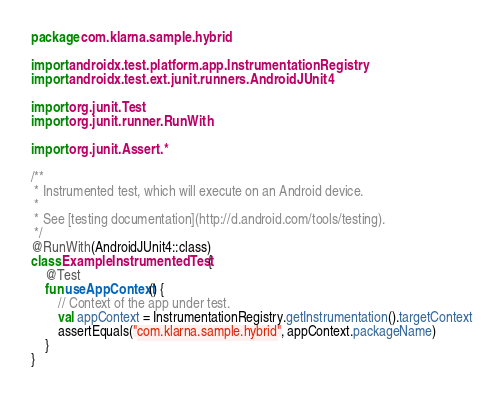Convert code to text. <code><loc_0><loc_0><loc_500><loc_500><_Kotlin_>package com.klarna.sample.hybrid

import androidx.test.platform.app.InstrumentationRegistry
import androidx.test.ext.junit.runners.AndroidJUnit4

import org.junit.Test
import org.junit.runner.RunWith

import org.junit.Assert.*

/**
 * Instrumented test, which will execute on an Android device.
 *
 * See [testing documentation](http://d.android.com/tools/testing).
 */
@RunWith(AndroidJUnit4::class)
class ExampleInstrumentedTest {
    @Test
    fun useAppContext() {
        // Context of the app under test.
        val appContext = InstrumentationRegistry.getInstrumentation().targetContext
        assertEquals("com.klarna.sample.hybrid", appContext.packageName)
    }
}
</code> 